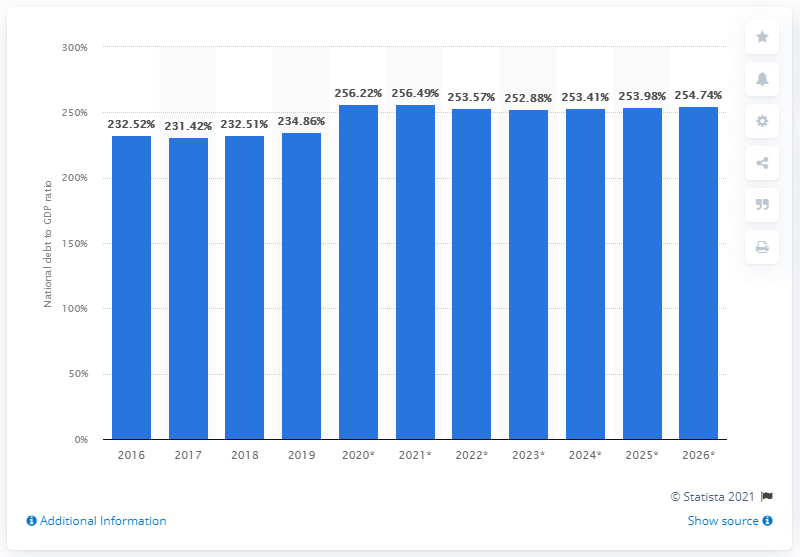Highlight a few significant elements in this photo. In 2019, Japan's national debt constituted approximately 234.86% of the country's gross domestic product (GDP). 